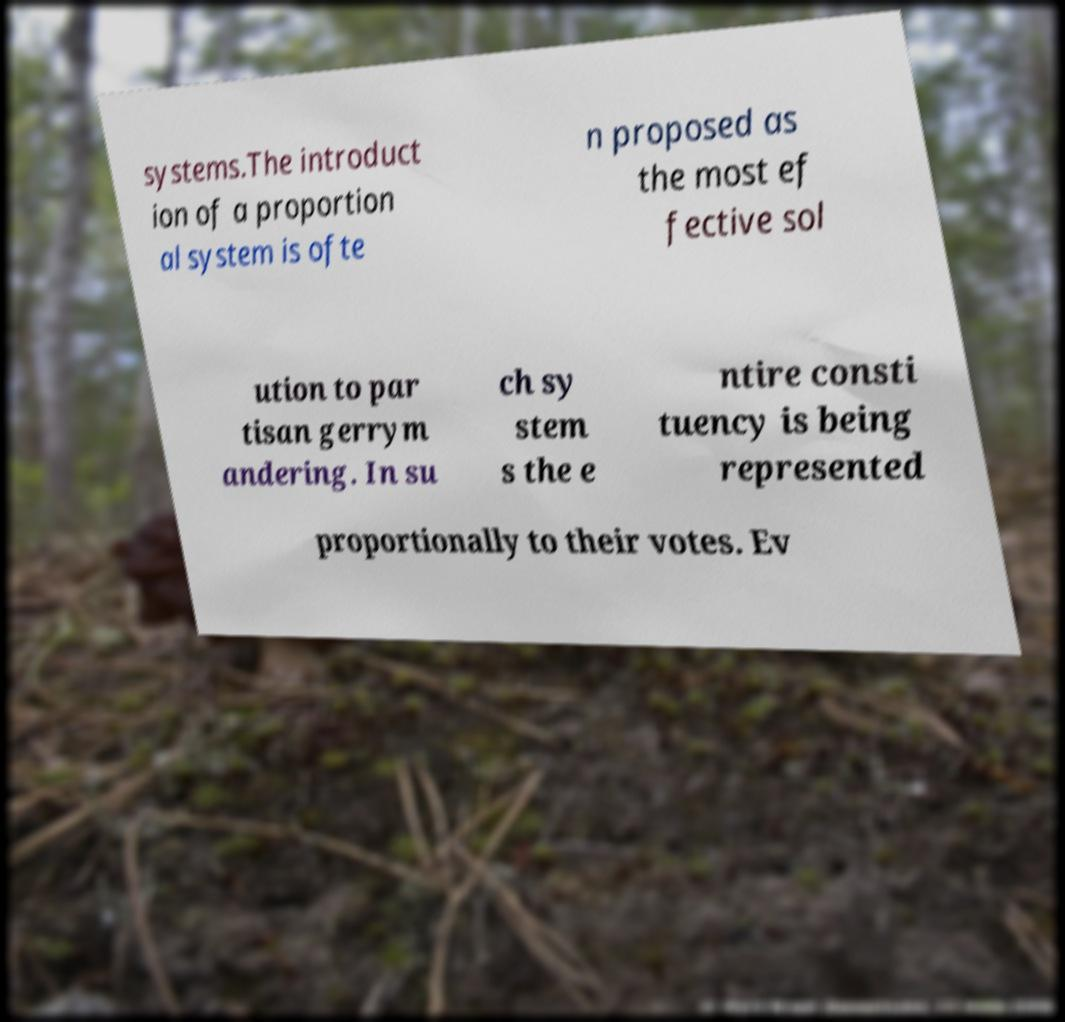I need the written content from this picture converted into text. Can you do that? systems.The introduct ion of a proportion al system is ofte n proposed as the most ef fective sol ution to par tisan gerrym andering. In su ch sy stem s the e ntire consti tuency is being represented proportionally to their votes. Ev 